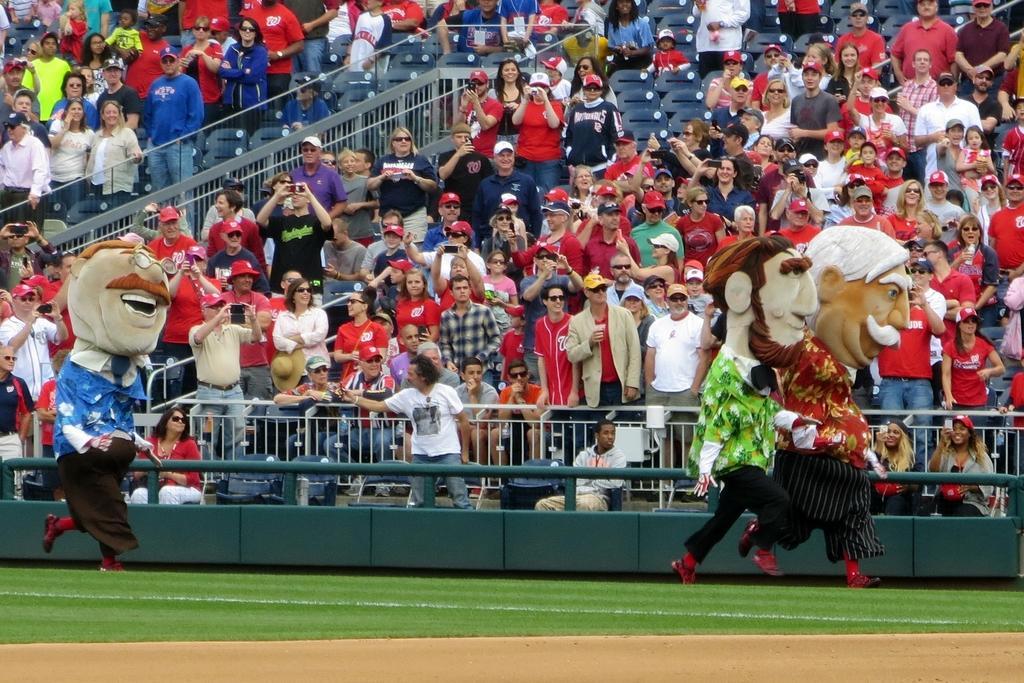Please provide a concise description of this image. In the foreground of the image we can see a ground. In the middle of the image we can see some persons are dressed up in different manner. On the top of the image we can see some people are sitting on the chairs and some other persons are taking photographs. 